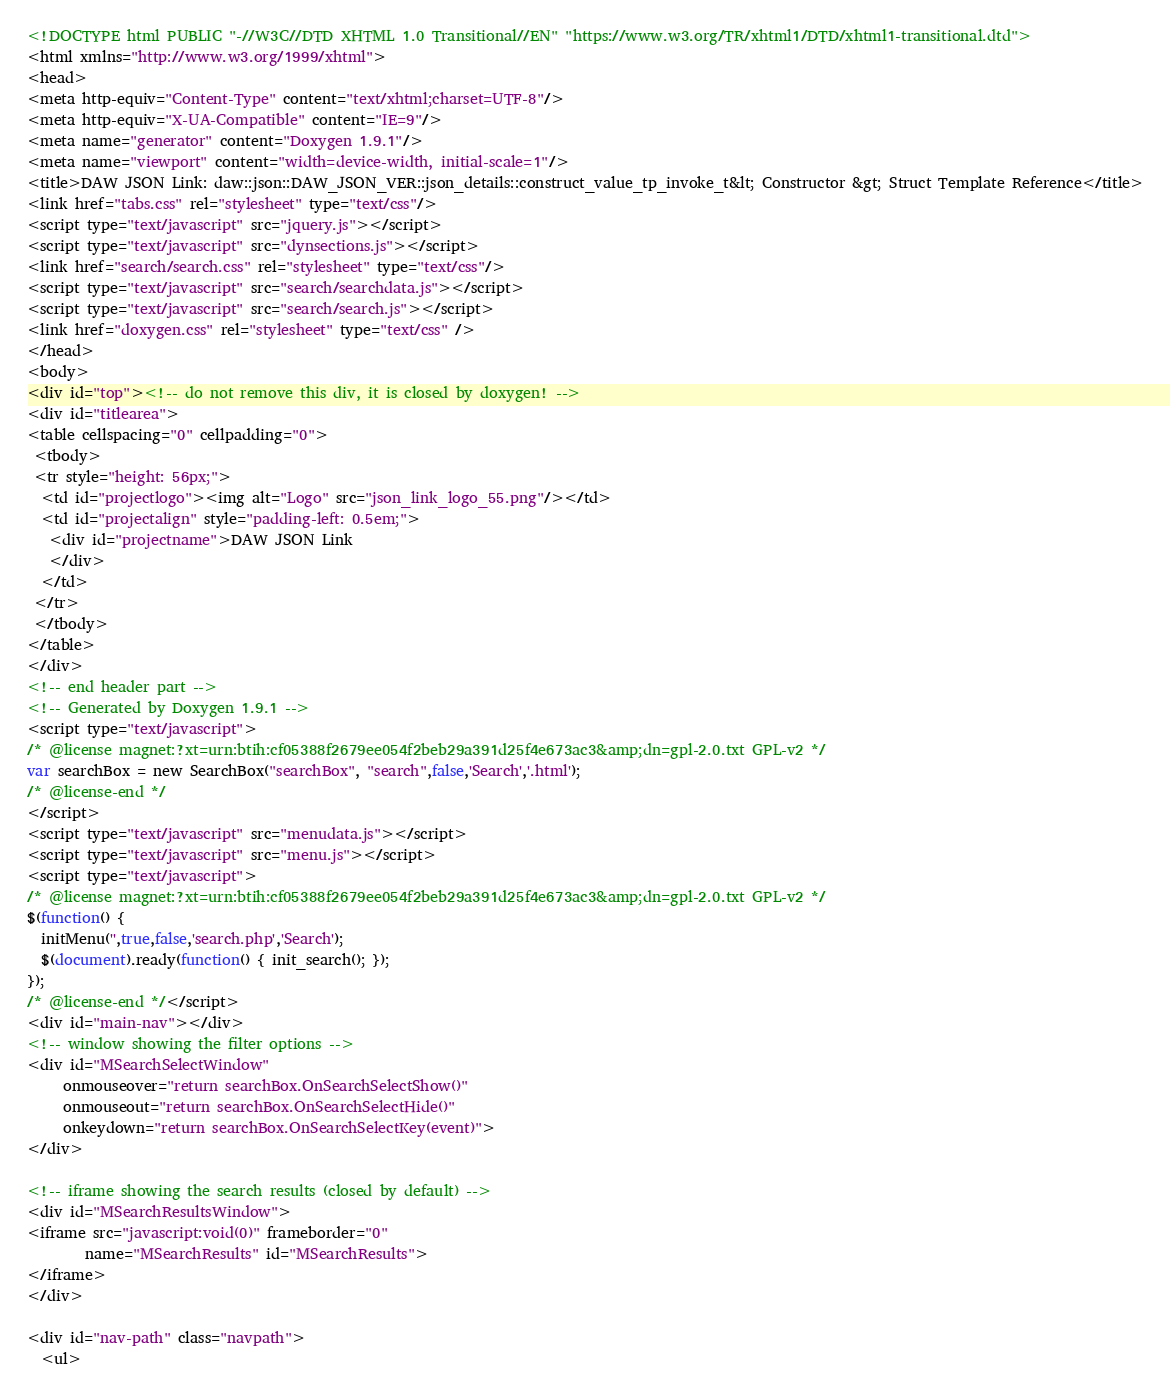<code> <loc_0><loc_0><loc_500><loc_500><_HTML_><!DOCTYPE html PUBLIC "-//W3C//DTD XHTML 1.0 Transitional//EN" "https://www.w3.org/TR/xhtml1/DTD/xhtml1-transitional.dtd">
<html xmlns="http://www.w3.org/1999/xhtml">
<head>
<meta http-equiv="Content-Type" content="text/xhtml;charset=UTF-8"/>
<meta http-equiv="X-UA-Compatible" content="IE=9"/>
<meta name="generator" content="Doxygen 1.9.1"/>
<meta name="viewport" content="width=device-width, initial-scale=1"/>
<title>DAW JSON Link: daw::json::DAW_JSON_VER::json_details::construct_value_tp_invoke_t&lt; Constructor &gt; Struct Template Reference</title>
<link href="tabs.css" rel="stylesheet" type="text/css"/>
<script type="text/javascript" src="jquery.js"></script>
<script type="text/javascript" src="dynsections.js"></script>
<link href="search/search.css" rel="stylesheet" type="text/css"/>
<script type="text/javascript" src="search/searchdata.js"></script>
<script type="text/javascript" src="search/search.js"></script>
<link href="doxygen.css" rel="stylesheet" type="text/css" />
</head>
<body>
<div id="top"><!-- do not remove this div, it is closed by doxygen! -->
<div id="titlearea">
<table cellspacing="0" cellpadding="0">
 <tbody>
 <tr style="height: 56px;">
  <td id="projectlogo"><img alt="Logo" src="json_link_logo_55.png"/></td>
  <td id="projectalign" style="padding-left: 0.5em;">
   <div id="projectname">DAW JSON Link
   </div>
  </td>
 </tr>
 </tbody>
</table>
</div>
<!-- end header part -->
<!-- Generated by Doxygen 1.9.1 -->
<script type="text/javascript">
/* @license magnet:?xt=urn:btih:cf05388f2679ee054f2beb29a391d25f4e673ac3&amp;dn=gpl-2.0.txt GPL-v2 */
var searchBox = new SearchBox("searchBox", "search",false,'Search','.html');
/* @license-end */
</script>
<script type="text/javascript" src="menudata.js"></script>
<script type="text/javascript" src="menu.js"></script>
<script type="text/javascript">
/* @license magnet:?xt=urn:btih:cf05388f2679ee054f2beb29a391d25f4e673ac3&amp;dn=gpl-2.0.txt GPL-v2 */
$(function() {
  initMenu('',true,false,'search.php','Search');
  $(document).ready(function() { init_search(); });
});
/* @license-end */</script>
<div id="main-nav"></div>
<!-- window showing the filter options -->
<div id="MSearchSelectWindow"
     onmouseover="return searchBox.OnSearchSelectShow()"
     onmouseout="return searchBox.OnSearchSelectHide()"
     onkeydown="return searchBox.OnSearchSelectKey(event)">
</div>

<!-- iframe showing the search results (closed by default) -->
<div id="MSearchResultsWindow">
<iframe src="javascript:void(0)" frameborder="0" 
        name="MSearchResults" id="MSearchResults">
</iframe>
</div>

<div id="nav-path" class="navpath">
  <ul></code> 